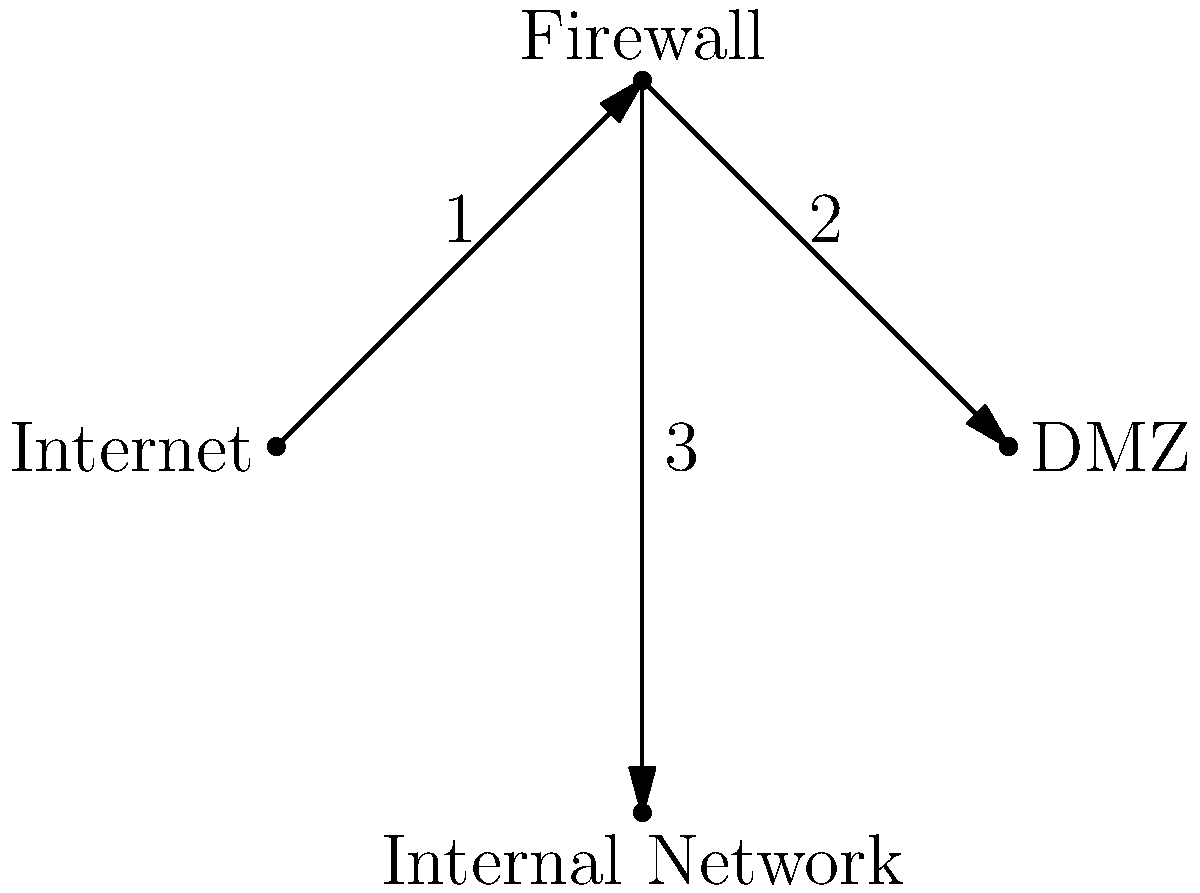Given the network diagram, which path would an incoming packet from the Internet to an internal server most likely follow, assuming a properly configured firewall? To answer this question, we need to analyze the network diagram and understand the typical flow of packets through a firewall-protected network:

1. The packet originates from the Internet (node A).
2. It first encounters the firewall (node B). This is the primary security checkpoint.
3. The firewall has two potential paths for the packet:
   a. Path 2: to the DMZ (Demilitarized Zone, node C)
   b. Path 3: to the Internal Network (node D)

4. In a properly configured network:
   - The DMZ hosts public-facing services (e.g., web servers, email servers).
   - The Internal Network contains sensitive resources and is more restricted.

5. For security reasons, direct access from the Internet to the Internal Network is typically blocked.

6. Therefore, the most likely path for an incoming packet to reach an internal server would be:
   Internet (A) → Firewall (B) → DMZ (C)

7. From the DMZ, controlled communication to the Internal Network may be allowed, but this would be a separate process not shown in the diagram.

Given these considerations, the most secure and likely path for an incoming packet from the Internet to eventually reach an internal server would be through paths 1 and 2.
Answer: 1 → 2 